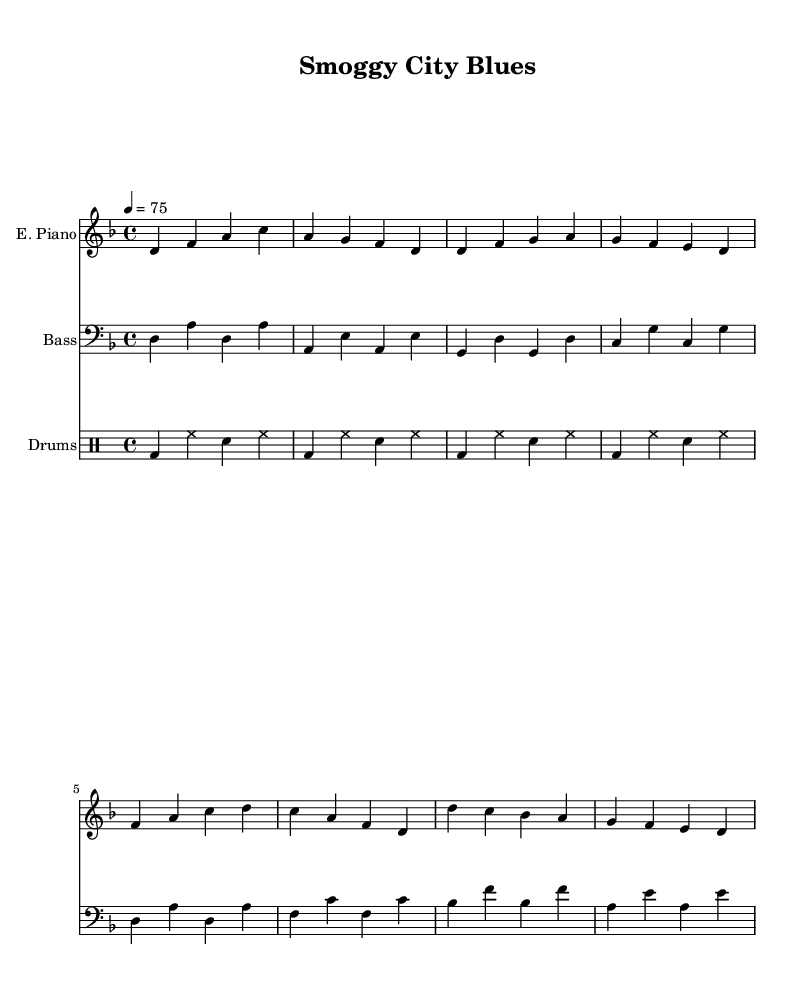What is the key signature of this music? The key signature appears at the beginning of the staff and indicates that it is D minor, which contains one flat (B flat).
Answer: D minor What is the time signature of the piece? The time signature is found at the start of the music and is displayed as 4/4, meaning there are four beats in each measure and the quarter note gets one beat.
Answer: 4/4 What is the tempo marking of this piece? The tempo marking is provided above the sections of music, showing a metronome marking of 75 beats per minute, which indicates a slow and steady pace.
Answer: 75 How many measures are in the verse section? By counting the groups of notes separated by vertical lines (bar lines), we find there are four measures in the verse section.
Answer: 4 What unique musical elements are present in Rhythm and Blues as represented here? Rhythm and Blues often includes syncopated rhythms, call-and-response patterns, and rich harmonies. Here there is a syncopated drum rhythm and a laid-back groove typical in neo-soul styles, reflecting the genre's influence.
Answer: Syncopation Which instrument plays the highest pitch in the score? The highest pitch is found in the electric piano part, which plays notes such as C and D in higher octaves compared to the bass guitar part, which stays in lower octaves.
Answer: Electric Piano 